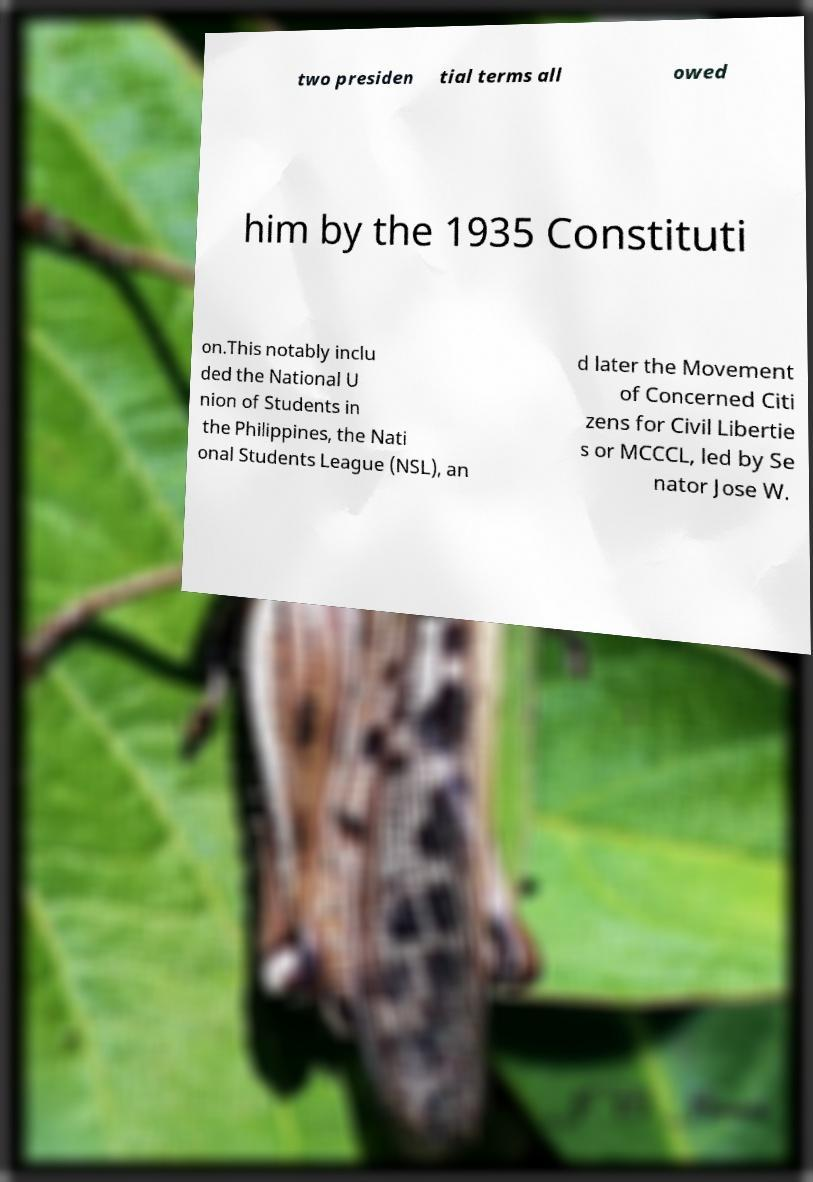What messages or text are displayed in this image? I need them in a readable, typed format. two presiden tial terms all owed him by the 1935 Constituti on.This notably inclu ded the National U nion of Students in the Philippines, the Nati onal Students League (NSL), an d later the Movement of Concerned Citi zens for Civil Libertie s or MCCCL, led by Se nator Jose W. 